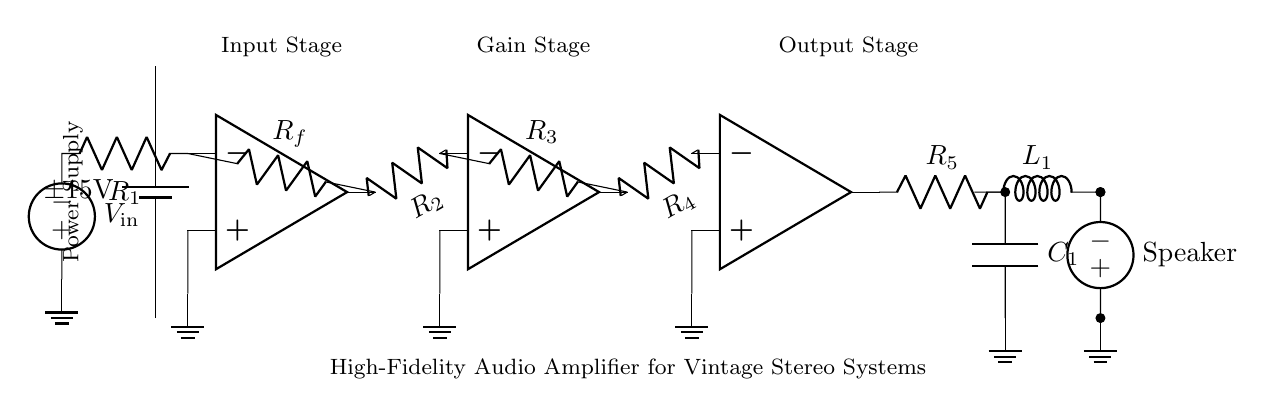What is the power supply voltage of this circuit? The power supply voltage is indicated at the battery, which shows a value of plus and minus fifteen volts. This suggests a dual power supply configuration.
Answer: plus and minus fifteen volts How many operational amplifiers are used in the circuit? By examining the circuit diagram, we can see that there are three operational amplifiers present, each performing a different function in the amplification process.
Answer: three What is the purpose of resistor Rf in the input stage? Resistor Rf, which connects between the output of the first op-amp and its inverting input, is used to set the gain of the amplifier by creating a feedback loop that stabilizes the circuit.
Answer: gain setting What is the function of the capacitor C1 in the output stage? The capacitor C1 in the output stage is used primarily for filtering the output signal and providing stability to the amplifier's performance by coupling and decoupling AC signals while blocking DC components.
Answer: filtering What type of circuit is this? The circuit is classified as a high-fidelity audio amplifier designed for vintage stereo systems, as indicated by the detailed components used for audio amplification and the labeling in the diagram.
Answer: high-fidelity audio amplifier Which component is connected to the speaker in the output stage? The output stage connects to the speaker through an inductor labeled as L1, which helps in impedance matching and filtering in order to deliver a clean output signal to the speaker.
Answer: inductor L1 What does resistor R2 do in the gain stage? Resistor R2, connecting from the inverting input of the second op-amp to the output of the first op-amp, is part of the gain stage and functions similarly to Rf by affecting the gain of the second stage of amplification.
Answer: gain adjustment 